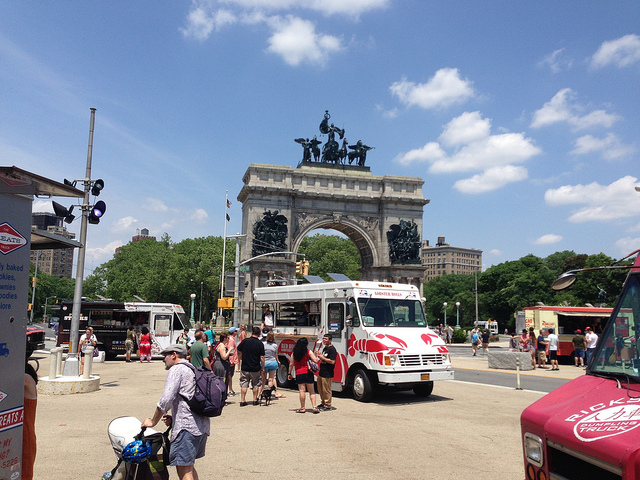Explain the visual content of the image in great detail. The image portrays a vibrant scene around a grand monument, which is prominently featured in the background. The monument is an arch structure topped with imposing sculptures that seem to depict historical or mythological figures. To the left and right of the monument, food trucks are parked, serving visitors and creating a lively atmosphere. A variety of people are present, including tourists and locals, some with strollers, backpacks, and other personal items. The foreground of the image is bustling with activity, with several individuals gathered around, possibly queuing or socializing. The weather appears pleasant, with clear skies and scattered clouds, enhancing the overall cheerful ambiance of the scene. 